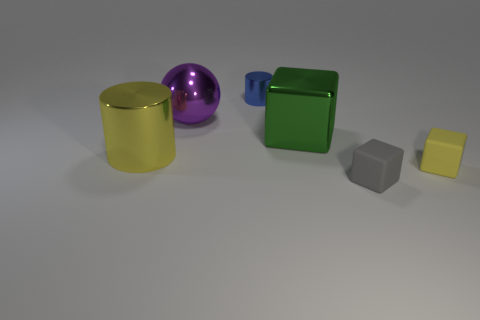Is there a sense of balance in the composition of this image? The image presents a harmonious composition with a balance of shapes and colors. The placement of objects appears deliberate, with colors and forms evenly distributed, creating a sense of equilibrium and visual appeal. No single object dominates the scene, and the variety of shapes and sizes adds to the balanced aesthetic. 